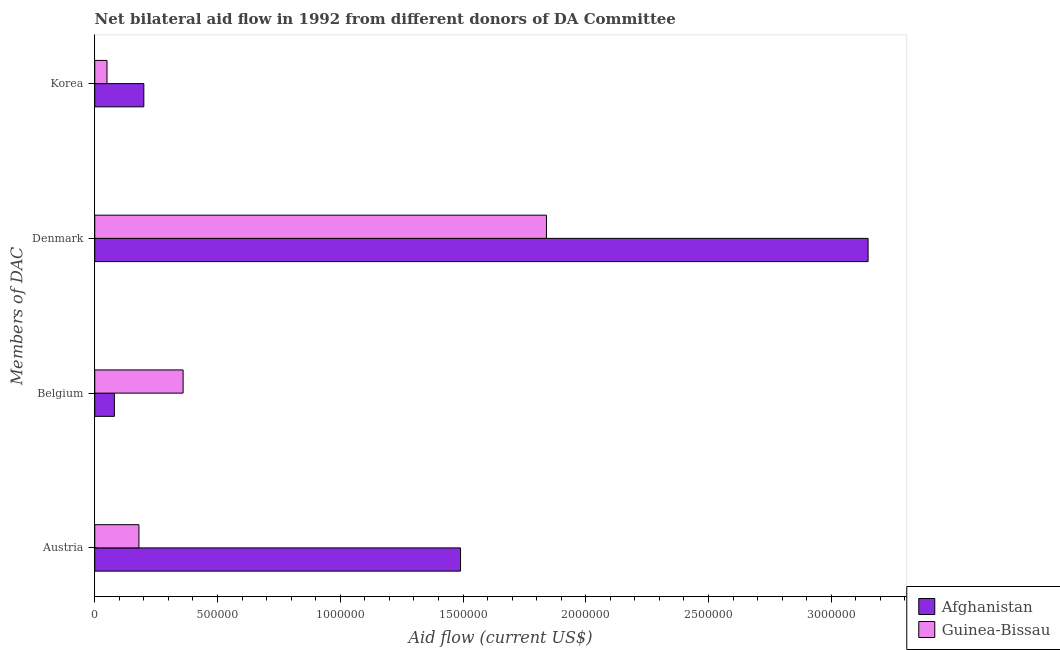Are the number of bars per tick equal to the number of legend labels?
Provide a short and direct response. Yes. Are the number of bars on each tick of the Y-axis equal?
Keep it short and to the point. Yes. What is the label of the 3rd group of bars from the top?
Ensure brevity in your answer.  Belgium. What is the amount of aid given by korea in Guinea-Bissau?
Your response must be concise. 5.00e+04. Across all countries, what is the maximum amount of aid given by korea?
Make the answer very short. 2.00e+05. Across all countries, what is the minimum amount of aid given by belgium?
Your answer should be compact. 8.00e+04. In which country was the amount of aid given by belgium maximum?
Offer a terse response. Guinea-Bissau. In which country was the amount of aid given by denmark minimum?
Provide a short and direct response. Guinea-Bissau. What is the total amount of aid given by austria in the graph?
Provide a short and direct response. 1.67e+06. What is the difference between the amount of aid given by denmark in Afghanistan and that in Guinea-Bissau?
Offer a very short reply. 1.31e+06. What is the difference between the amount of aid given by belgium in Afghanistan and the amount of aid given by austria in Guinea-Bissau?
Your response must be concise. -1.00e+05. What is the average amount of aid given by denmark per country?
Your answer should be very brief. 2.50e+06. What is the difference between the amount of aid given by belgium and amount of aid given by denmark in Afghanistan?
Ensure brevity in your answer.  -3.07e+06. What is the ratio of the amount of aid given by denmark in Guinea-Bissau to that in Afghanistan?
Give a very brief answer. 0.58. What is the difference between the highest and the lowest amount of aid given by belgium?
Make the answer very short. 2.80e+05. In how many countries, is the amount of aid given by austria greater than the average amount of aid given by austria taken over all countries?
Give a very brief answer. 1. Is the sum of the amount of aid given by korea in Guinea-Bissau and Afghanistan greater than the maximum amount of aid given by denmark across all countries?
Your answer should be very brief. No. What does the 2nd bar from the top in Austria represents?
Your response must be concise. Afghanistan. What does the 1st bar from the bottom in Denmark represents?
Your answer should be very brief. Afghanistan. Is it the case that in every country, the sum of the amount of aid given by austria and amount of aid given by belgium is greater than the amount of aid given by denmark?
Make the answer very short. No. Are all the bars in the graph horizontal?
Ensure brevity in your answer.  Yes. What is the difference between two consecutive major ticks on the X-axis?
Offer a very short reply. 5.00e+05. Are the values on the major ticks of X-axis written in scientific E-notation?
Provide a short and direct response. No. Does the graph contain grids?
Provide a short and direct response. No. Where does the legend appear in the graph?
Offer a very short reply. Bottom right. How are the legend labels stacked?
Keep it short and to the point. Vertical. What is the title of the graph?
Your response must be concise. Net bilateral aid flow in 1992 from different donors of DA Committee. What is the label or title of the X-axis?
Provide a short and direct response. Aid flow (current US$). What is the label or title of the Y-axis?
Provide a succinct answer. Members of DAC. What is the Aid flow (current US$) of Afghanistan in Austria?
Keep it short and to the point. 1.49e+06. What is the Aid flow (current US$) of Afghanistan in Belgium?
Ensure brevity in your answer.  8.00e+04. What is the Aid flow (current US$) of Guinea-Bissau in Belgium?
Offer a terse response. 3.60e+05. What is the Aid flow (current US$) of Afghanistan in Denmark?
Your answer should be very brief. 3.15e+06. What is the Aid flow (current US$) of Guinea-Bissau in Denmark?
Provide a succinct answer. 1.84e+06. Across all Members of DAC, what is the maximum Aid flow (current US$) in Afghanistan?
Offer a terse response. 3.15e+06. Across all Members of DAC, what is the maximum Aid flow (current US$) in Guinea-Bissau?
Give a very brief answer. 1.84e+06. Across all Members of DAC, what is the minimum Aid flow (current US$) of Guinea-Bissau?
Offer a very short reply. 5.00e+04. What is the total Aid flow (current US$) of Afghanistan in the graph?
Make the answer very short. 4.92e+06. What is the total Aid flow (current US$) in Guinea-Bissau in the graph?
Provide a succinct answer. 2.43e+06. What is the difference between the Aid flow (current US$) of Afghanistan in Austria and that in Belgium?
Your answer should be very brief. 1.41e+06. What is the difference between the Aid flow (current US$) in Afghanistan in Austria and that in Denmark?
Ensure brevity in your answer.  -1.66e+06. What is the difference between the Aid flow (current US$) of Guinea-Bissau in Austria and that in Denmark?
Offer a very short reply. -1.66e+06. What is the difference between the Aid flow (current US$) in Afghanistan in Austria and that in Korea?
Your answer should be very brief. 1.29e+06. What is the difference between the Aid flow (current US$) in Guinea-Bissau in Austria and that in Korea?
Provide a short and direct response. 1.30e+05. What is the difference between the Aid flow (current US$) of Afghanistan in Belgium and that in Denmark?
Offer a terse response. -3.07e+06. What is the difference between the Aid flow (current US$) in Guinea-Bissau in Belgium and that in Denmark?
Offer a very short reply. -1.48e+06. What is the difference between the Aid flow (current US$) in Afghanistan in Denmark and that in Korea?
Your answer should be very brief. 2.95e+06. What is the difference between the Aid flow (current US$) of Guinea-Bissau in Denmark and that in Korea?
Give a very brief answer. 1.79e+06. What is the difference between the Aid flow (current US$) in Afghanistan in Austria and the Aid flow (current US$) in Guinea-Bissau in Belgium?
Provide a short and direct response. 1.13e+06. What is the difference between the Aid flow (current US$) in Afghanistan in Austria and the Aid flow (current US$) in Guinea-Bissau in Denmark?
Keep it short and to the point. -3.50e+05. What is the difference between the Aid flow (current US$) of Afghanistan in Austria and the Aid flow (current US$) of Guinea-Bissau in Korea?
Ensure brevity in your answer.  1.44e+06. What is the difference between the Aid flow (current US$) in Afghanistan in Belgium and the Aid flow (current US$) in Guinea-Bissau in Denmark?
Offer a terse response. -1.76e+06. What is the difference between the Aid flow (current US$) in Afghanistan in Belgium and the Aid flow (current US$) in Guinea-Bissau in Korea?
Make the answer very short. 3.00e+04. What is the difference between the Aid flow (current US$) in Afghanistan in Denmark and the Aid flow (current US$) in Guinea-Bissau in Korea?
Offer a terse response. 3.10e+06. What is the average Aid flow (current US$) of Afghanistan per Members of DAC?
Ensure brevity in your answer.  1.23e+06. What is the average Aid flow (current US$) in Guinea-Bissau per Members of DAC?
Offer a terse response. 6.08e+05. What is the difference between the Aid flow (current US$) in Afghanistan and Aid flow (current US$) in Guinea-Bissau in Austria?
Make the answer very short. 1.31e+06. What is the difference between the Aid flow (current US$) in Afghanistan and Aid flow (current US$) in Guinea-Bissau in Belgium?
Give a very brief answer. -2.80e+05. What is the difference between the Aid flow (current US$) in Afghanistan and Aid flow (current US$) in Guinea-Bissau in Denmark?
Give a very brief answer. 1.31e+06. What is the ratio of the Aid flow (current US$) of Afghanistan in Austria to that in Belgium?
Keep it short and to the point. 18.62. What is the ratio of the Aid flow (current US$) of Guinea-Bissau in Austria to that in Belgium?
Your response must be concise. 0.5. What is the ratio of the Aid flow (current US$) in Afghanistan in Austria to that in Denmark?
Give a very brief answer. 0.47. What is the ratio of the Aid flow (current US$) of Guinea-Bissau in Austria to that in Denmark?
Provide a succinct answer. 0.1. What is the ratio of the Aid flow (current US$) of Afghanistan in Austria to that in Korea?
Offer a very short reply. 7.45. What is the ratio of the Aid flow (current US$) in Guinea-Bissau in Austria to that in Korea?
Provide a succinct answer. 3.6. What is the ratio of the Aid flow (current US$) of Afghanistan in Belgium to that in Denmark?
Your answer should be compact. 0.03. What is the ratio of the Aid flow (current US$) in Guinea-Bissau in Belgium to that in Denmark?
Offer a terse response. 0.2. What is the ratio of the Aid flow (current US$) of Afghanistan in Belgium to that in Korea?
Your response must be concise. 0.4. What is the ratio of the Aid flow (current US$) of Afghanistan in Denmark to that in Korea?
Your answer should be very brief. 15.75. What is the ratio of the Aid flow (current US$) of Guinea-Bissau in Denmark to that in Korea?
Keep it short and to the point. 36.8. What is the difference between the highest and the second highest Aid flow (current US$) in Afghanistan?
Offer a terse response. 1.66e+06. What is the difference between the highest and the second highest Aid flow (current US$) in Guinea-Bissau?
Offer a very short reply. 1.48e+06. What is the difference between the highest and the lowest Aid flow (current US$) in Afghanistan?
Your answer should be very brief. 3.07e+06. What is the difference between the highest and the lowest Aid flow (current US$) of Guinea-Bissau?
Keep it short and to the point. 1.79e+06. 